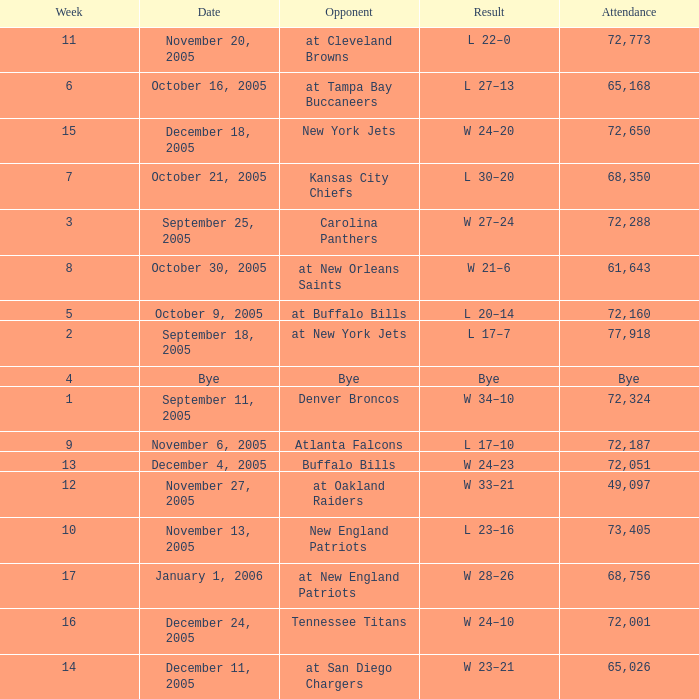Could you parse the entire table? {'header': ['Week', 'Date', 'Opponent', 'Result', 'Attendance'], 'rows': [['11', 'November 20, 2005', 'at Cleveland Browns', 'L 22–0', '72,773'], ['6', 'October 16, 2005', 'at Tampa Bay Buccaneers', 'L 27–13', '65,168'], ['15', 'December 18, 2005', 'New York Jets', 'W 24–20', '72,650'], ['7', 'October 21, 2005', 'Kansas City Chiefs', 'L 30–20', '68,350'], ['3', 'September 25, 2005', 'Carolina Panthers', 'W 27–24', '72,288'], ['8', 'October 30, 2005', 'at New Orleans Saints', 'W 21–6', '61,643'], ['5', 'October 9, 2005', 'at Buffalo Bills', 'L 20–14', '72,160'], ['2', 'September 18, 2005', 'at New York Jets', 'L 17–7', '77,918'], ['4', 'Bye', 'Bye', 'Bye', 'Bye'], ['1', 'September 11, 2005', 'Denver Broncos', 'W 34–10', '72,324'], ['9', 'November 6, 2005', 'Atlanta Falcons', 'L 17–10', '72,187'], ['13', 'December 4, 2005', 'Buffalo Bills', 'W 24–23', '72,051'], ['12', 'November 27, 2005', 'at Oakland Raiders', 'W 33–21', '49,097'], ['10', 'November 13, 2005', 'New England Patriots', 'L 23–16', '73,405'], ['17', 'January 1, 2006', 'at New England Patriots', 'W 28–26', '68,756'], ['16', 'December 24, 2005', 'Tennessee Titans', 'W 24–10', '72,001'], ['14', 'December 11, 2005', 'at San Diego Chargers', 'W 23–21', '65,026']]} In what Week was the Attendance 49,097? 12.0. 